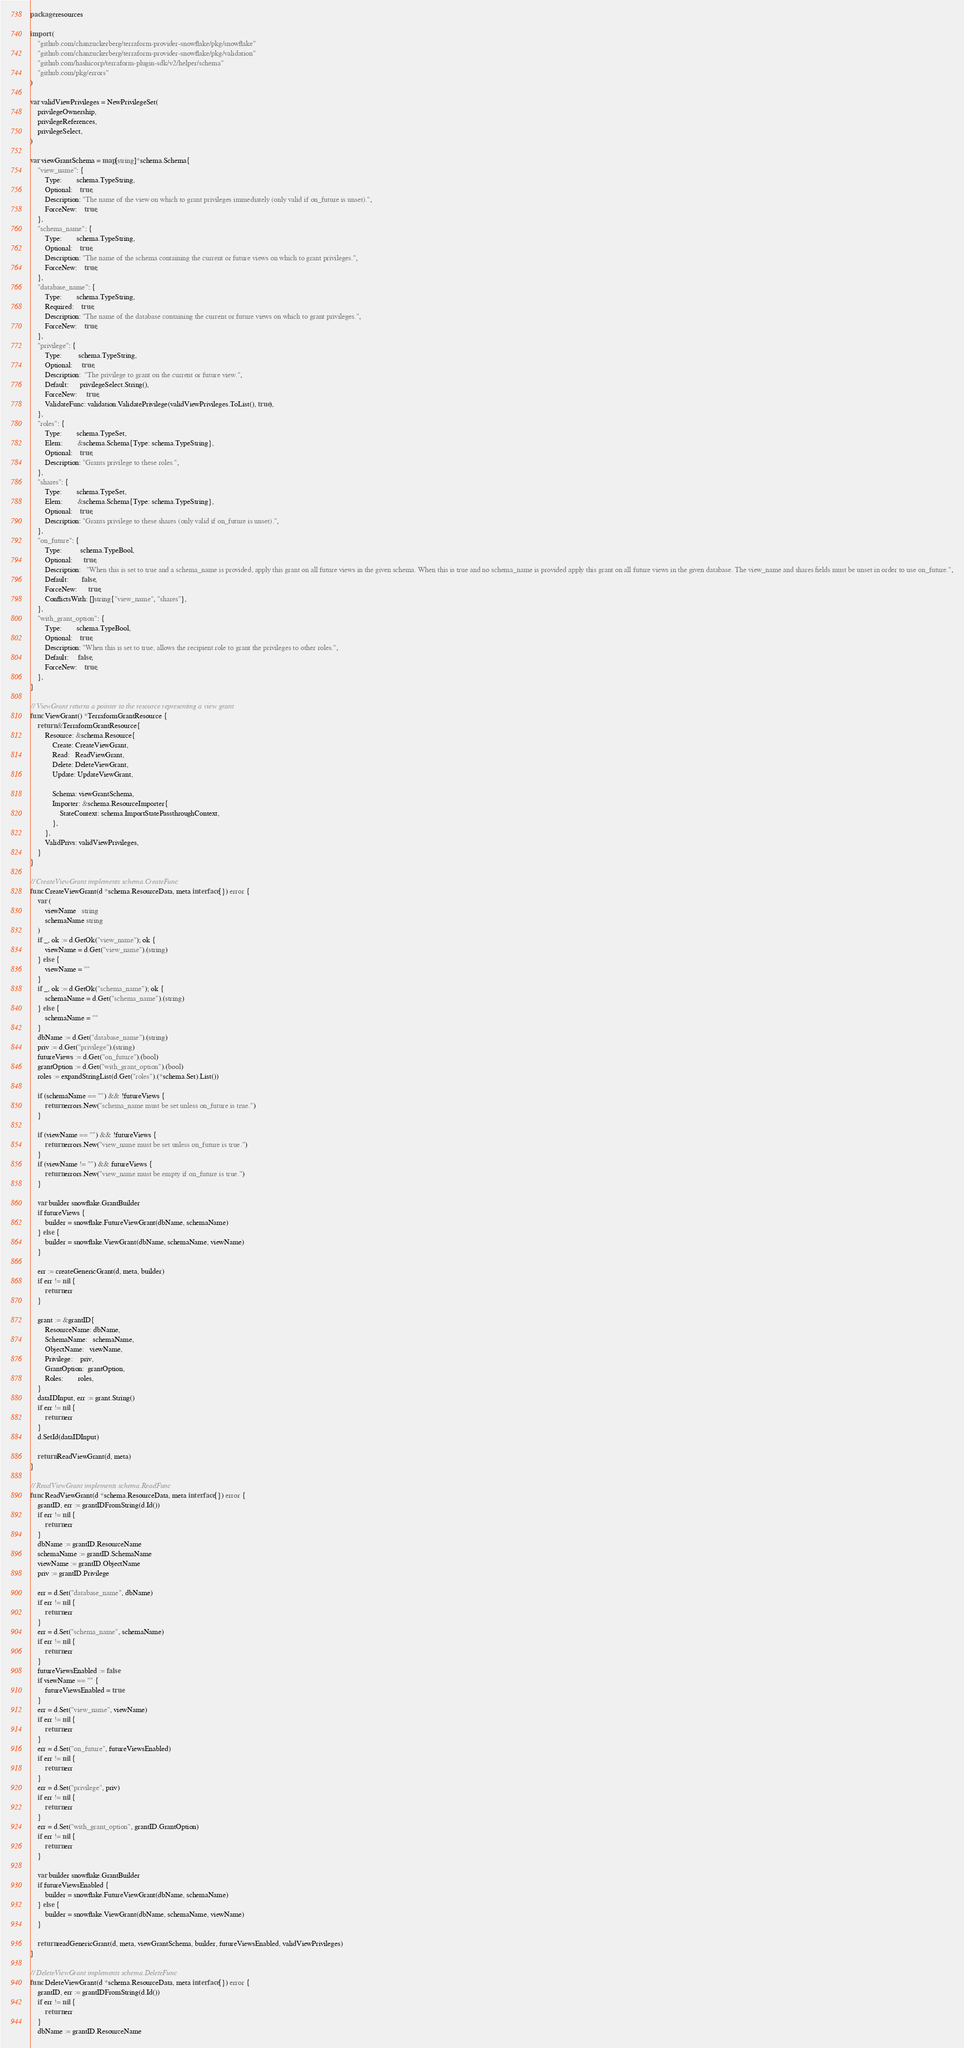Convert code to text. <code><loc_0><loc_0><loc_500><loc_500><_Go_>package resources

import (
	"github.com/chanzuckerberg/terraform-provider-snowflake/pkg/snowflake"
	"github.com/chanzuckerberg/terraform-provider-snowflake/pkg/validation"
	"github.com/hashicorp/terraform-plugin-sdk/v2/helper/schema"
	"github.com/pkg/errors"
)

var validViewPrivileges = NewPrivilegeSet(
	privilegeOwnership,
	privilegeReferences,
	privilegeSelect,
)

var viewGrantSchema = map[string]*schema.Schema{
	"view_name": {
		Type:        schema.TypeString,
		Optional:    true,
		Description: "The name of the view on which to grant privileges immediately (only valid if on_future is unset).",
		ForceNew:    true,
	},
	"schema_name": {
		Type:        schema.TypeString,
		Optional:    true,
		Description: "The name of the schema containing the current or future views on which to grant privileges.",
		ForceNew:    true,
	},
	"database_name": {
		Type:        schema.TypeString,
		Required:    true,
		Description: "The name of the database containing the current or future views on which to grant privileges.",
		ForceNew:    true,
	},
	"privilege": {
		Type:         schema.TypeString,
		Optional:     true,
		Description:  "The privilege to grant on the current or future view.",
		Default:      privilegeSelect.String(),
		ForceNew:     true,
		ValidateFunc: validation.ValidatePrivilege(validViewPrivileges.ToList(), true),
	},
	"roles": {
		Type:        schema.TypeSet,
		Elem:        &schema.Schema{Type: schema.TypeString},
		Optional:    true,
		Description: "Grants privilege to these roles.",
	},
	"shares": {
		Type:        schema.TypeSet,
		Elem:        &schema.Schema{Type: schema.TypeString},
		Optional:    true,
		Description: "Grants privilege to these shares (only valid if on_future is unset).",
	},
	"on_future": {
		Type:          schema.TypeBool,
		Optional:      true,
		Description:   "When this is set to true and a schema_name is provided, apply this grant on all future views in the given schema. When this is true and no schema_name is provided apply this grant on all future views in the given database. The view_name and shares fields must be unset in order to use on_future.",
		Default:       false,
		ForceNew:      true,
		ConflictsWith: []string{"view_name", "shares"},
	},
	"with_grant_option": {
		Type:        schema.TypeBool,
		Optional:    true,
		Description: "When this is set to true, allows the recipient role to grant the privileges to other roles.",
		Default:     false,
		ForceNew:    true,
	},
}

// ViewGrant returns a pointer to the resource representing a view grant
func ViewGrant() *TerraformGrantResource {
	return &TerraformGrantResource{
		Resource: &schema.Resource{
			Create: CreateViewGrant,
			Read:   ReadViewGrant,
			Delete: DeleteViewGrant,
			Update: UpdateViewGrant,

			Schema: viewGrantSchema,
			Importer: &schema.ResourceImporter{
				StateContext: schema.ImportStatePassthroughContext,
			},
		},
		ValidPrivs: validViewPrivileges,
	}
}

// CreateViewGrant implements schema.CreateFunc
func CreateViewGrant(d *schema.ResourceData, meta interface{}) error {
	var (
		viewName   string
		schemaName string
	)
	if _, ok := d.GetOk("view_name"); ok {
		viewName = d.Get("view_name").(string)
	} else {
		viewName = ""
	}
	if _, ok := d.GetOk("schema_name"); ok {
		schemaName = d.Get("schema_name").(string)
	} else {
		schemaName = ""
	}
	dbName := d.Get("database_name").(string)
	priv := d.Get("privilege").(string)
	futureViews := d.Get("on_future").(bool)
	grantOption := d.Get("with_grant_option").(bool)
	roles := expandStringList(d.Get("roles").(*schema.Set).List())

	if (schemaName == "") && !futureViews {
		return errors.New("schema_name must be set unless on_future is true.")
	}

	if (viewName == "") && !futureViews {
		return errors.New("view_name must be set unless on_future is true.")
	}
	if (viewName != "") && futureViews {
		return errors.New("view_name must be empty if on_future is true.")
	}

	var builder snowflake.GrantBuilder
	if futureViews {
		builder = snowflake.FutureViewGrant(dbName, schemaName)
	} else {
		builder = snowflake.ViewGrant(dbName, schemaName, viewName)
	}

	err := createGenericGrant(d, meta, builder)
	if err != nil {
		return err
	}

	grant := &grantID{
		ResourceName: dbName,
		SchemaName:   schemaName,
		ObjectName:   viewName,
		Privilege:    priv,
		GrantOption:  grantOption,
		Roles:        roles,
	}
	dataIDInput, err := grant.String()
	if err != nil {
		return err
	}
	d.SetId(dataIDInput)

	return ReadViewGrant(d, meta)
}

// ReadViewGrant implements schema.ReadFunc
func ReadViewGrant(d *schema.ResourceData, meta interface{}) error {
	grantID, err := grantIDFromString(d.Id())
	if err != nil {
		return err
	}
	dbName := grantID.ResourceName
	schemaName := grantID.SchemaName
	viewName := grantID.ObjectName
	priv := grantID.Privilege

	err = d.Set("database_name", dbName)
	if err != nil {
		return err
	}
	err = d.Set("schema_name", schemaName)
	if err != nil {
		return err
	}
	futureViewsEnabled := false
	if viewName == "" {
		futureViewsEnabled = true
	}
	err = d.Set("view_name", viewName)
	if err != nil {
		return err
	}
	err = d.Set("on_future", futureViewsEnabled)
	if err != nil {
		return err
	}
	err = d.Set("privilege", priv)
	if err != nil {
		return err
	}
	err = d.Set("with_grant_option", grantID.GrantOption)
	if err != nil {
		return err
	}

	var builder snowflake.GrantBuilder
	if futureViewsEnabled {
		builder = snowflake.FutureViewGrant(dbName, schemaName)
	} else {
		builder = snowflake.ViewGrant(dbName, schemaName, viewName)
	}

	return readGenericGrant(d, meta, viewGrantSchema, builder, futureViewsEnabled, validViewPrivileges)
}

// DeleteViewGrant implements schema.DeleteFunc
func DeleteViewGrant(d *schema.ResourceData, meta interface{}) error {
	grantID, err := grantIDFromString(d.Id())
	if err != nil {
		return err
	}
	dbName := grantID.ResourceName</code> 